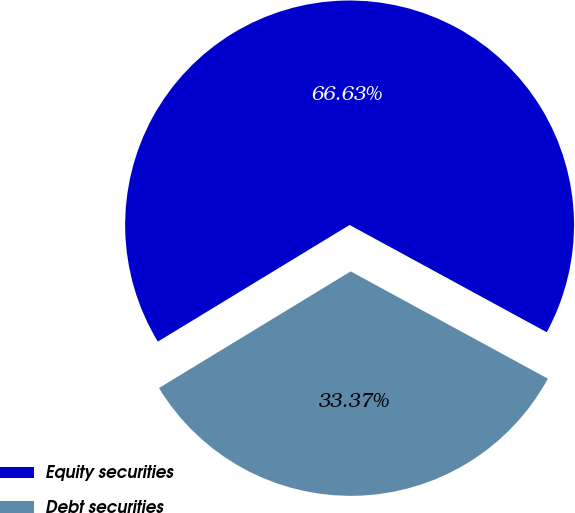Convert chart. <chart><loc_0><loc_0><loc_500><loc_500><pie_chart><fcel>Equity securities<fcel>Debt securities<nl><fcel>66.63%<fcel>33.37%<nl></chart> 